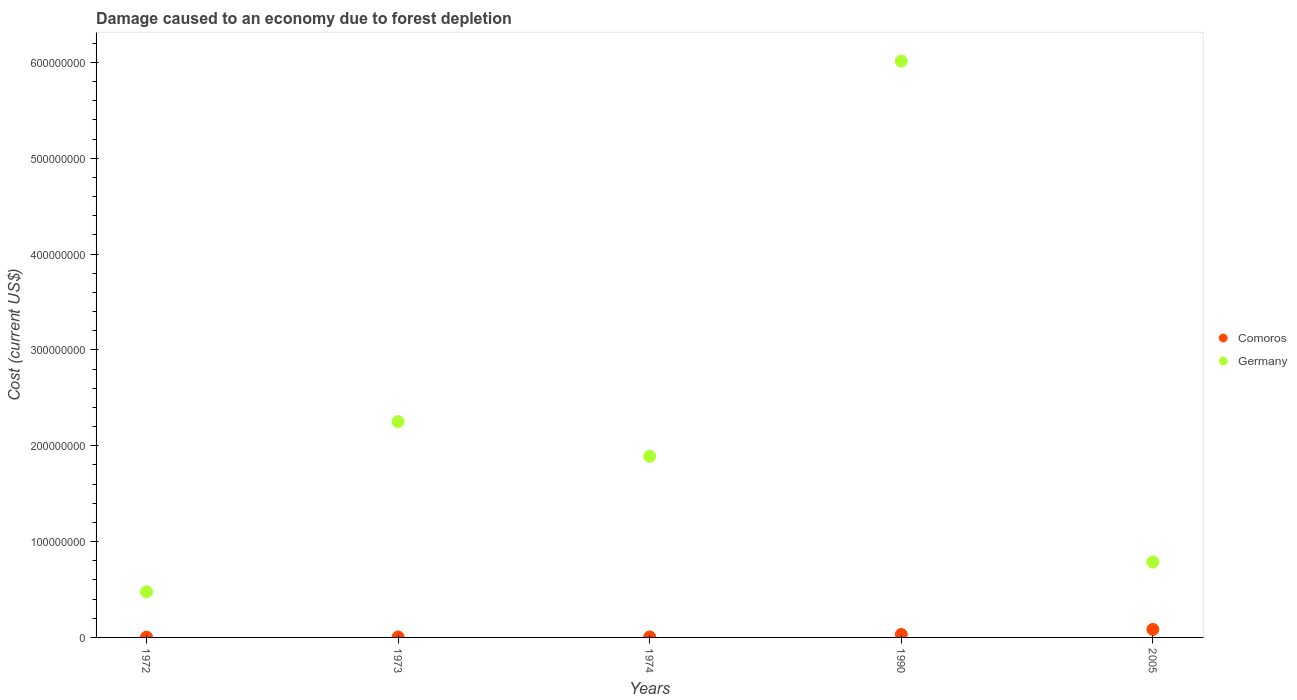How many different coloured dotlines are there?
Your answer should be compact. 2. What is the cost of damage caused due to forest depletion in Comoros in 1974?
Give a very brief answer. 4.98e+05. Across all years, what is the maximum cost of damage caused due to forest depletion in Comoros?
Your answer should be very brief. 8.37e+06. Across all years, what is the minimum cost of damage caused due to forest depletion in Germany?
Offer a very short reply. 4.76e+07. In which year was the cost of damage caused due to forest depletion in Germany maximum?
Offer a terse response. 1990. What is the total cost of damage caused due to forest depletion in Germany in the graph?
Offer a terse response. 1.14e+09. What is the difference between the cost of damage caused due to forest depletion in Comoros in 1973 and that in 1990?
Keep it short and to the point. -2.64e+06. What is the difference between the cost of damage caused due to forest depletion in Germany in 1972 and the cost of damage caused due to forest depletion in Comoros in 1974?
Offer a very short reply. 4.71e+07. What is the average cost of damage caused due to forest depletion in Comoros per year?
Offer a very short reply. 2.54e+06. In the year 1974, what is the difference between the cost of damage caused due to forest depletion in Comoros and cost of damage caused due to forest depletion in Germany?
Provide a short and direct response. -1.89e+08. In how many years, is the cost of damage caused due to forest depletion in Comoros greater than 280000000 US$?
Give a very brief answer. 0. What is the ratio of the cost of damage caused due to forest depletion in Comoros in 1972 to that in 2005?
Provide a short and direct response. 0.03. Is the cost of damage caused due to forest depletion in Germany in 1974 less than that in 1990?
Offer a terse response. Yes. Is the difference between the cost of damage caused due to forest depletion in Comoros in 1990 and 2005 greater than the difference between the cost of damage caused due to forest depletion in Germany in 1990 and 2005?
Offer a terse response. No. What is the difference between the highest and the second highest cost of damage caused due to forest depletion in Germany?
Your response must be concise. 3.76e+08. What is the difference between the highest and the lowest cost of damage caused due to forest depletion in Comoros?
Your response must be concise. 8.12e+06. In how many years, is the cost of damage caused due to forest depletion in Comoros greater than the average cost of damage caused due to forest depletion in Comoros taken over all years?
Provide a succinct answer. 2. Does the cost of damage caused due to forest depletion in Comoros monotonically increase over the years?
Your answer should be very brief. Yes. How many dotlines are there?
Provide a short and direct response. 2. How many years are there in the graph?
Your answer should be very brief. 5. What is the difference between two consecutive major ticks on the Y-axis?
Ensure brevity in your answer.  1.00e+08. Are the values on the major ticks of Y-axis written in scientific E-notation?
Offer a very short reply. No. Does the graph contain grids?
Offer a terse response. No. Where does the legend appear in the graph?
Provide a succinct answer. Center right. What is the title of the graph?
Give a very brief answer. Damage caused to an economy due to forest depletion. What is the label or title of the X-axis?
Offer a very short reply. Years. What is the label or title of the Y-axis?
Your answer should be compact. Cost (current US$). What is the Cost (current US$) in Comoros in 1972?
Your response must be concise. 2.54e+05. What is the Cost (current US$) of Germany in 1972?
Provide a short and direct response. 4.76e+07. What is the Cost (current US$) of Comoros in 1973?
Your response must be concise. 4.73e+05. What is the Cost (current US$) of Germany in 1973?
Offer a terse response. 2.25e+08. What is the Cost (current US$) in Comoros in 1974?
Provide a succinct answer. 4.98e+05. What is the Cost (current US$) of Germany in 1974?
Provide a succinct answer. 1.89e+08. What is the Cost (current US$) in Comoros in 1990?
Give a very brief answer. 3.11e+06. What is the Cost (current US$) of Germany in 1990?
Keep it short and to the point. 6.01e+08. What is the Cost (current US$) of Comoros in 2005?
Provide a short and direct response. 8.37e+06. What is the Cost (current US$) in Germany in 2005?
Provide a short and direct response. 7.87e+07. Across all years, what is the maximum Cost (current US$) of Comoros?
Offer a very short reply. 8.37e+06. Across all years, what is the maximum Cost (current US$) of Germany?
Make the answer very short. 6.01e+08. Across all years, what is the minimum Cost (current US$) of Comoros?
Make the answer very short. 2.54e+05. Across all years, what is the minimum Cost (current US$) of Germany?
Provide a short and direct response. 4.76e+07. What is the total Cost (current US$) of Comoros in the graph?
Offer a terse response. 1.27e+07. What is the total Cost (current US$) in Germany in the graph?
Give a very brief answer. 1.14e+09. What is the difference between the Cost (current US$) in Comoros in 1972 and that in 1973?
Offer a terse response. -2.19e+05. What is the difference between the Cost (current US$) in Germany in 1972 and that in 1973?
Provide a short and direct response. -1.78e+08. What is the difference between the Cost (current US$) in Comoros in 1972 and that in 1974?
Make the answer very short. -2.44e+05. What is the difference between the Cost (current US$) of Germany in 1972 and that in 1974?
Your answer should be compact. -1.41e+08. What is the difference between the Cost (current US$) of Comoros in 1972 and that in 1990?
Your answer should be compact. -2.86e+06. What is the difference between the Cost (current US$) in Germany in 1972 and that in 1990?
Your answer should be very brief. -5.54e+08. What is the difference between the Cost (current US$) in Comoros in 1972 and that in 2005?
Provide a short and direct response. -8.12e+06. What is the difference between the Cost (current US$) of Germany in 1972 and that in 2005?
Give a very brief answer. -3.11e+07. What is the difference between the Cost (current US$) of Comoros in 1973 and that in 1974?
Give a very brief answer. -2.52e+04. What is the difference between the Cost (current US$) of Germany in 1973 and that in 1974?
Make the answer very short. 3.62e+07. What is the difference between the Cost (current US$) of Comoros in 1973 and that in 1990?
Your answer should be compact. -2.64e+06. What is the difference between the Cost (current US$) in Germany in 1973 and that in 1990?
Your answer should be compact. -3.76e+08. What is the difference between the Cost (current US$) in Comoros in 1973 and that in 2005?
Offer a terse response. -7.90e+06. What is the difference between the Cost (current US$) in Germany in 1973 and that in 2005?
Give a very brief answer. 1.46e+08. What is the difference between the Cost (current US$) in Comoros in 1974 and that in 1990?
Provide a succinct answer. -2.61e+06. What is the difference between the Cost (current US$) in Germany in 1974 and that in 1990?
Make the answer very short. -4.12e+08. What is the difference between the Cost (current US$) in Comoros in 1974 and that in 2005?
Your response must be concise. -7.87e+06. What is the difference between the Cost (current US$) in Germany in 1974 and that in 2005?
Offer a very short reply. 1.10e+08. What is the difference between the Cost (current US$) in Comoros in 1990 and that in 2005?
Give a very brief answer. -5.26e+06. What is the difference between the Cost (current US$) in Germany in 1990 and that in 2005?
Provide a short and direct response. 5.23e+08. What is the difference between the Cost (current US$) of Comoros in 1972 and the Cost (current US$) of Germany in 1973?
Keep it short and to the point. -2.25e+08. What is the difference between the Cost (current US$) of Comoros in 1972 and the Cost (current US$) of Germany in 1974?
Provide a short and direct response. -1.89e+08. What is the difference between the Cost (current US$) in Comoros in 1972 and the Cost (current US$) in Germany in 1990?
Offer a terse response. -6.01e+08. What is the difference between the Cost (current US$) of Comoros in 1972 and the Cost (current US$) of Germany in 2005?
Make the answer very short. -7.84e+07. What is the difference between the Cost (current US$) in Comoros in 1973 and the Cost (current US$) in Germany in 1974?
Ensure brevity in your answer.  -1.89e+08. What is the difference between the Cost (current US$) in Comoros in 1973 and the Cost (current US$) in Germany in 1990?
Offer a very short reply. -6.01e+08. What is the difference between the Cost (current US$) of Comoros in 1973 and the Cost (current US$) of Germany in 2005?
Give a very brief answer. -7.82e+07. What is the difference between the Cost (current US$) in Comoros in 1974 and the Cost (current US$) in Germany in 1990?
Offer a very short reply. -6.01e+08. What is the difference between the Cost (current US$) of Comoros in 1974 and the Cost (current US$) of Germany in 2005?
Your response must be concise. -7.82e+07. What is the difference between the Cost (current US$) in Comoros in 1990 and the Cost (current US$) in Germany in 2005?
Make the answer very short. -7.56e+07. What is the average Cost (current US$) in Comoros per year?
Ensure brevity in your answer.  2.54e+06. What is the average Cost (current US$) of Germany per year?
Give a very brief answer. 2.28e+08. In the year 1972, what is the difference between the Cost (current US$) of Comoros and Cost (current US$) of Germany?
Keep it short and to the point. -4.73e+07. In the year 1973, what is the difference between the Cost (current US$) of Comoros and Cost (current US$) of Germany?
Give a very brief answer. -2.25e+08. In the year 1974, what is the difference between the Cost (current US$) of Comoros and Cost (current US$) of Germany?
Your answer should be very brief. -1.89e+08. In the year 1990, what is the difference between the Cost (current US$) of Comoros and Cost (current US$) of Germany?
Provide a short and direct response. -5.98e+08. In the year 2005, what is the difference between the Cost (current US$) in Comoros and Cost (current US$) in Germany?
Your response must be concise. -7.03e+07. What is the ratio of the Cost (current US$) in Comoros in 1972 to that in 1973?
Give a very brief answer. 0.54. What is the ratio of the Cost (current US$) in Germany in 1972 to that in 1973?
Offer a terse response. 0.21. What is the ratio of the Cost (current US$) in Comoros in 1972 to that in 1974?
Ensure brevity in your answer.  0.51. What is the ratio of the Cost (current US$) in Germany in 1972 to that in 1974?
Keep it short and to the point. 0.25. What is the ratio of the Cost (current US$) of Comoros in 1972 to that in 1990?
Keep it short and to the point. 0.08. What is the ratio of the Cost (current US$) in Germany in 1972 to that in 1990?
Offer a terse response. 0.08. What is the ratio of the Cost (current US$) of Comoros in 1972 to that in 2005?
Provide a succinct answer. 0.03. What is the ratio of the Cost (current US$) of Germany in 1972 to that in 2005?
Provide a succinct answer. 0.6. What is the ratio of the Cost (current US$) of Comoros in 1973 to that in 1974?
Offer a very short reply. 0.95. What is the ratio of the Cost (current US$) of Germany in 1973 to that in 1974?
Ensure brevity in your answer.  1.19. What is the ratio of the Cost (current US$) of Comoros in 1973 to that in 1990?
Offer a very short reply. 0.15. What is the ratio of the Cost (current US$) of Germany in 1973 to that in 1990?
Offer a very short reply. 0.37. What is the ratio of the Cost (current US$) in Comoros in 1973 to that in 2005?
Your answer should be compact. 0.06. What is the ratio of the Cost (current US$) of Germany in 1973 to that in 2005?
Provide a short and direct response. 2.86. What is the ratio of the Cost (current US$) of Comoros in 1974 to that in 1990?
Your response must be concise. 0.16. What is the ratio of the Cost (current US$) of Germany in 1974 to that in 1990?
Give a very brief answer. 0.31. What is the ratio of the Cost (current US$) of Comoros in 1974 to that in 2005?
Provide a short and direct response. 0.06. What is the ratio of the Cost (current US$) in Germany in 1974 to that in 2005?
Keep it short and to the point. 2.4. What is the ratio of the Cost (current US$) of Comoros in 1990 to that in 2005?
Provide a short and direct response. 0.37. What is the ratio of the Cost (current US$) of Germany in 1990 to that in 2005?
Provide a succinct answer. 7.65. What is the difference between the highest and the second highest Cost (current US$) in Comoros?
Your answer should be very brief. 5.26e+06. What is the difference between the highest and the second highest Cost (current US$) of Germany?
Give a very brief answer. 3.76e+08. What is the difference between the highest and the lowest Cost (current US$) in Comoros?
Your answer should be compact. 8.12e+06. What is the difference between the highest and the lowest Cost (current US$) of Germany?
Make the answer very short. 5.54e+08. 